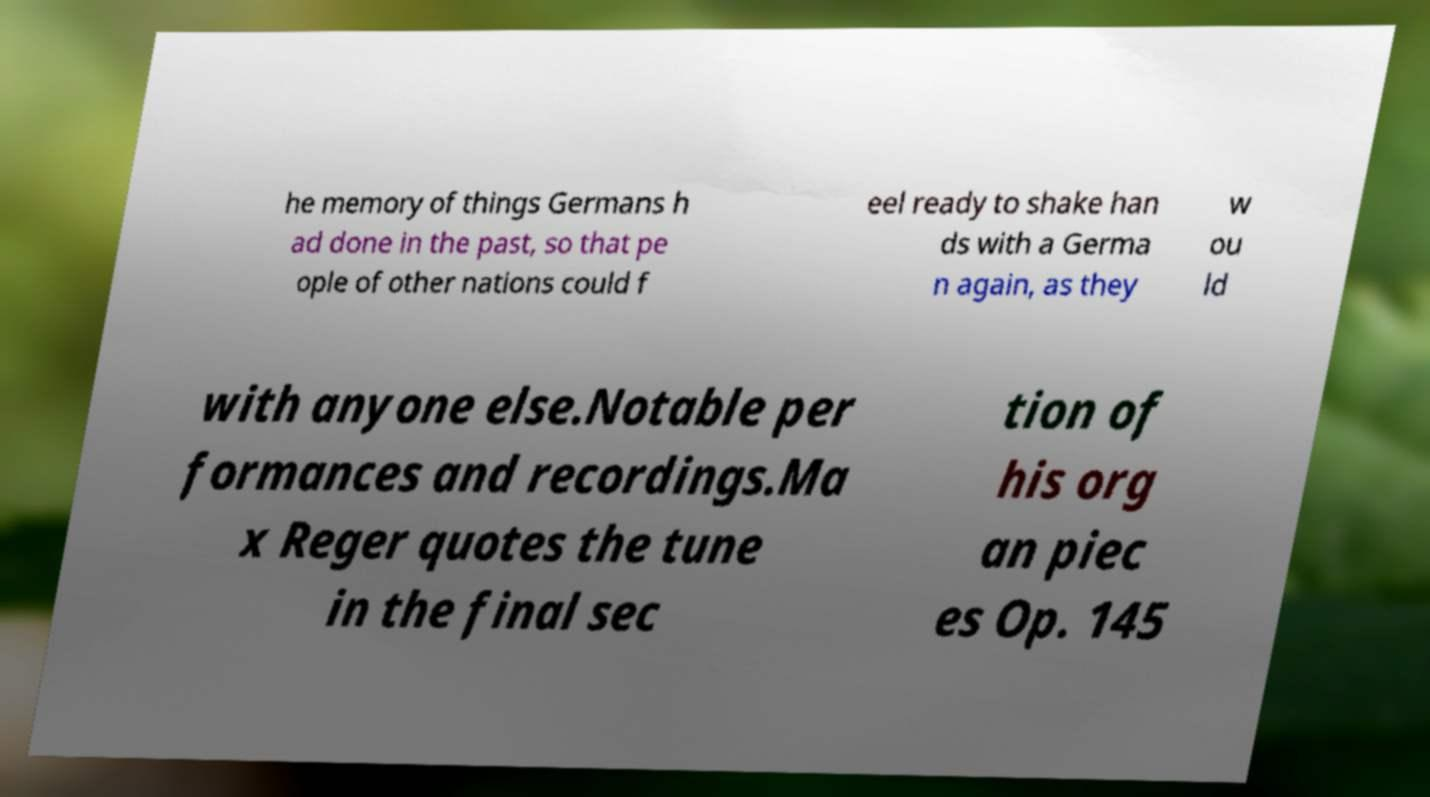I need the written content from this picture converted into text. Can you do that? he memory of things Germans h ad done in the past, so that pe ople of other nations could f eel ready to shake han ds with a Germa n again, as they w ou ld with anyone else.Notable per formances and recordings.Ma x Reger quotes the tune in the final sec tion of his org an piec es Op. 145 